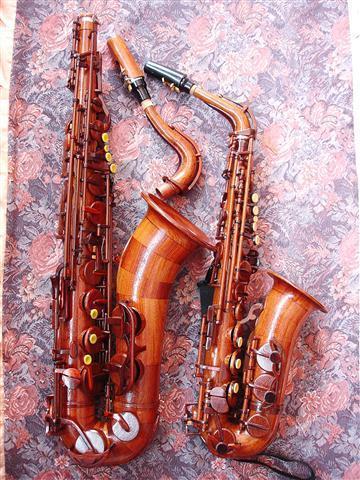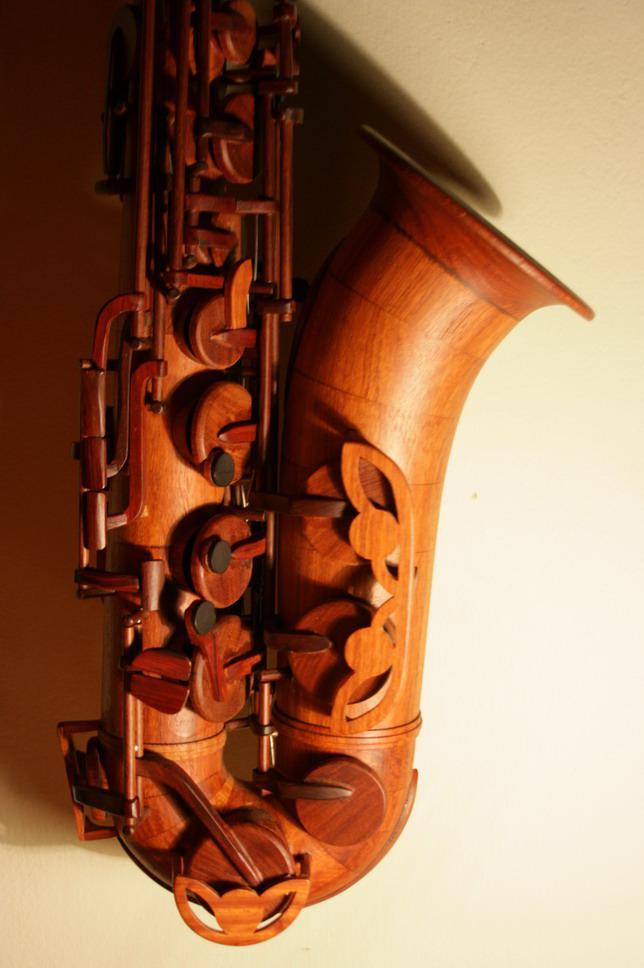The first image is the image on the left, the second image is the image on the right. Analyze the images presented: Is the assertion "The saxophones are standing against a white background" valid? Answer yes or no. No. 